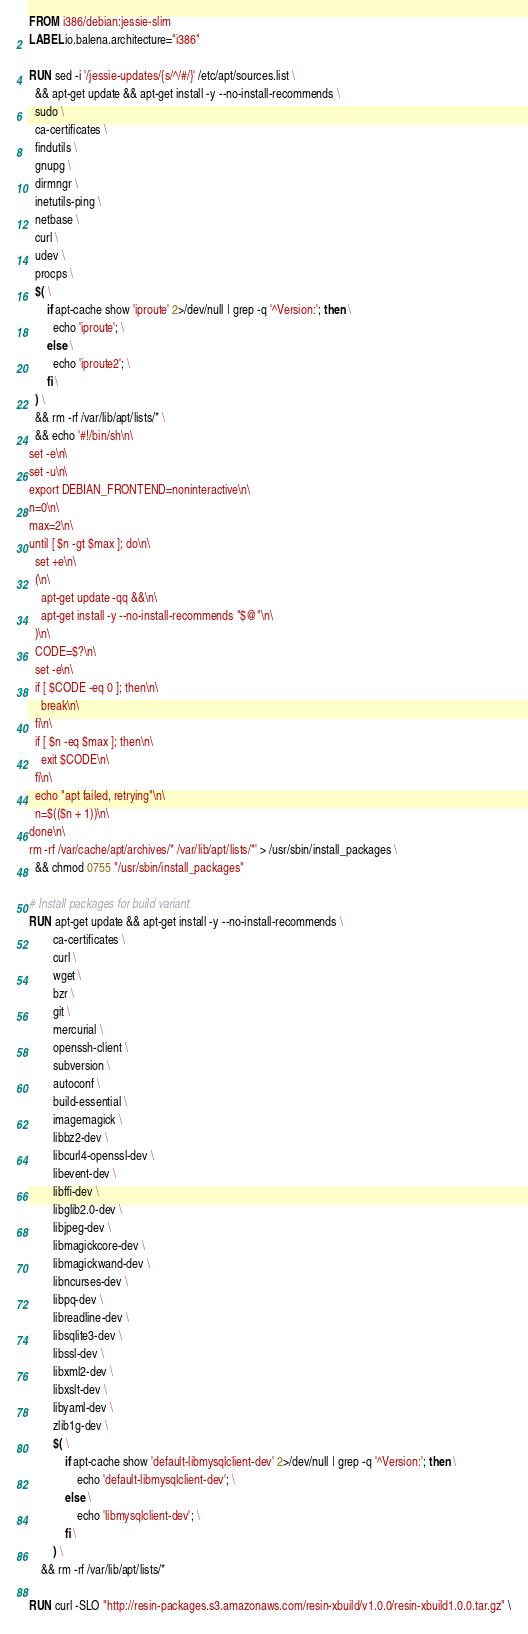Convert code to text. <code><loc_0><loc_0><loc_500><loc_500><_Dockerfile_>FROM i386/debian:jessie-slim
LABEL io.balena.architecture="i386"

RUN sed -i '/jessie-updates/{s/^/#/}' /etc/apt/sources.list \
  && apt-get update && apt-get install -y --no-install-recommends \
  sudo \
  ca-certificates \
  findutils \
  gnupg \
  dirmngr \
  inetutils-ping \
  netbase \
  curl \
  udev \
  procps \
  $( \
      if apt-cache show 'iproute' 2>/dev/null | grep -q '^Version:'; then \
        echo 'iproute'; \
      else \
        echo 'iproute2'; \
      fi \
  ) \
  && rm -rf /var/lib/apt/lists/* \
  && echo '#!/bin/sh\n\
set -e\n\
set -u\n\
export DEBIAN_FRONTEND=noninteractive\n\
n=0\n\
max=2\n\
until [ $n -gt $max ]; do\n\
  set +e\n\
  (\n\
    apt-get update -qq &&\n\
    apt-get install -y --no-install-recommends "$@"\n\
  )\n\
  CODE=$?\n\
  set -e\n\
  if [ $CODE -eq 0 ]; then\n\
    break\n\
  fi\n\
  if [ $n -eq $max ]; then\n\
    exit $CODE\n\
  fi\n\
  echo "apt failed, retrying"\n\
  n=$(($n + 1))\n\
done\n\
rm -rf /var/cache/apt/archives/* /var/lib/apt/lists/*' > /usr/sbin/install_packages \
  && chmod 0755 "/usr/sbin/install_packages"

# Install packages for build variant
RUN apt-get update && apt-get install -y --no-install-recommends \
		ca-certificates \
		curl \
		wget \
		bzr \
		git \
		mercurial \
		openssh-client \
		subversion \
		autoconf \
		build-essential \
		imagemagick \
		libbz2-dev \
		libcurl4-openssl-dev \
		libevent-dev \
		libffi-dev \
		libglib2.0-dev \
		libjpeg-dev \
		libmagickcore-dev \
		libmagickwand-dev \
		libncurses-dev \
		libpq-dev \
		libreadline-dev \
		libsqlite3-dev \
		libssl-dev \
		libxml2-dev \
		libxslt-dev \
		libyaml-dev \
		zlib1g-dev \
		$( \
			if apt-cache show 'default-libmysqlclient-dev' 2>/dev/null | grep -q '^Version:'; then \
				echo 'default-libmysqlclient-dev'; \
			else \
				echo 'libmysqlclient-dev'; \
			fi \
		) \
	&& rm -rf /var/lib/apt/lists/*

RUN curl -SLO "http://resin-packages.s3.amazonaws.com/resin-xbuild/v1.0.0/resin-xbuild1.0.0.tar.gz" \</code> 